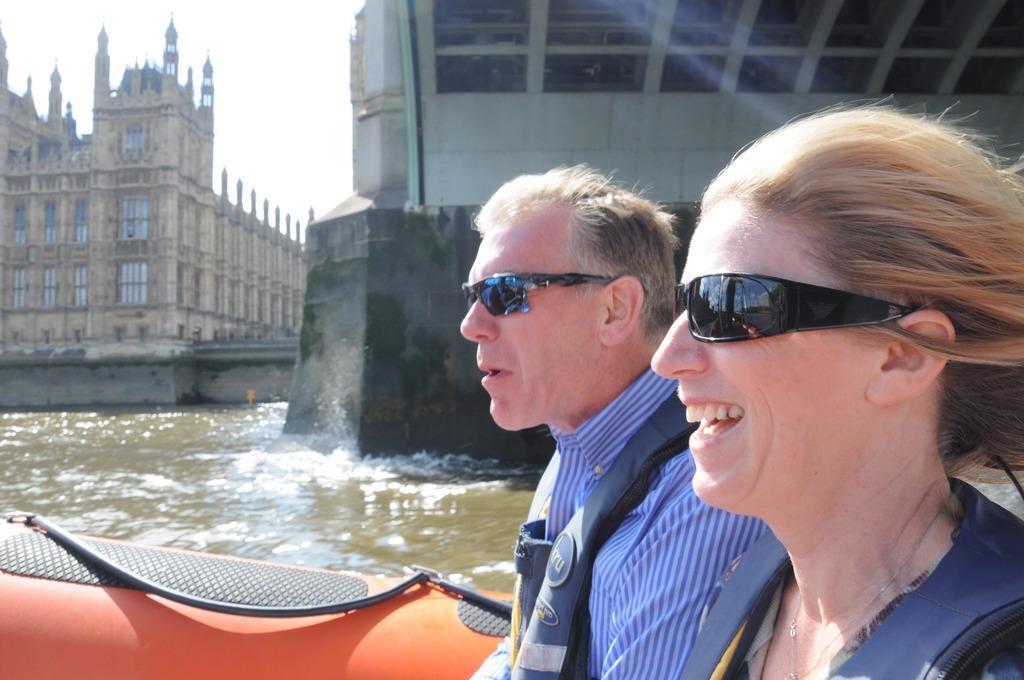How would you summarize this image in a sentence or two? In this image in the friend there are persons sitting on a boat and smiling. In the center there is water and in the background there is a castle and on the right side there is an object which is white in colour and there is a wall. 